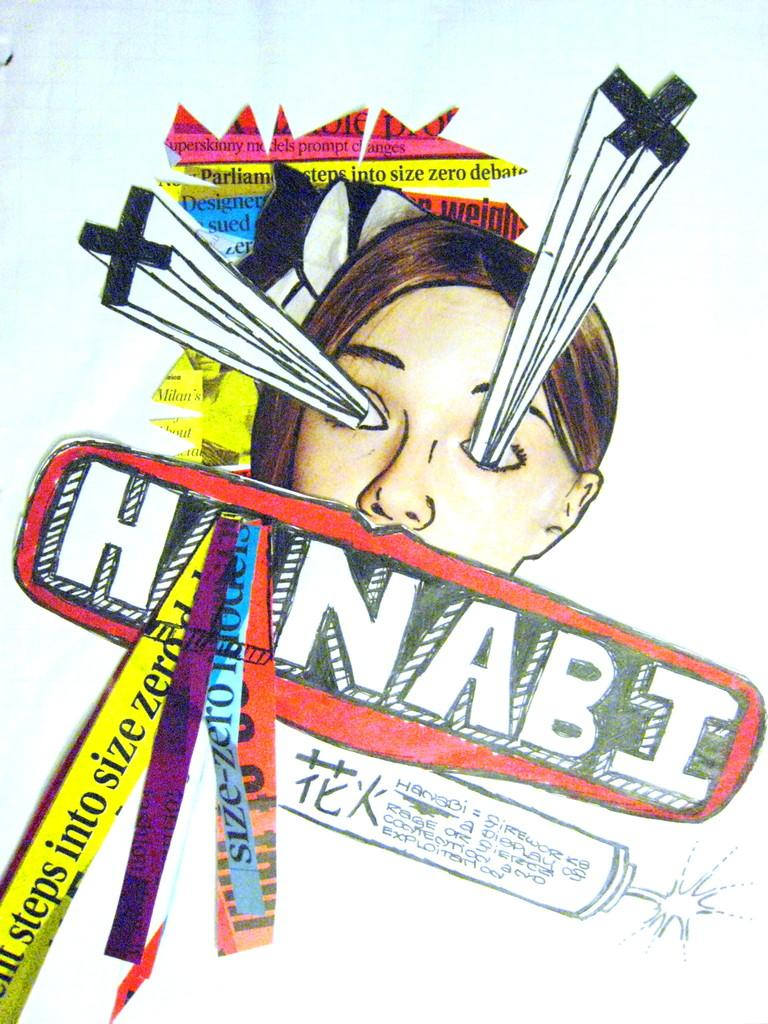What is the main subject of the image? There is a depiction of a person in the center of the image. Are there any words or letters in the image? Yes, there is text in the image. What else can be seen in the image besides the person and text? There are depictions of other objects in the image. What color is the background of the image? The background of the image is white in color. Can you tell me how many bears are present in the image? There are no bears depicted in the image. What type of order is being followed in the image? The image does not depict any specific order or sequence. 